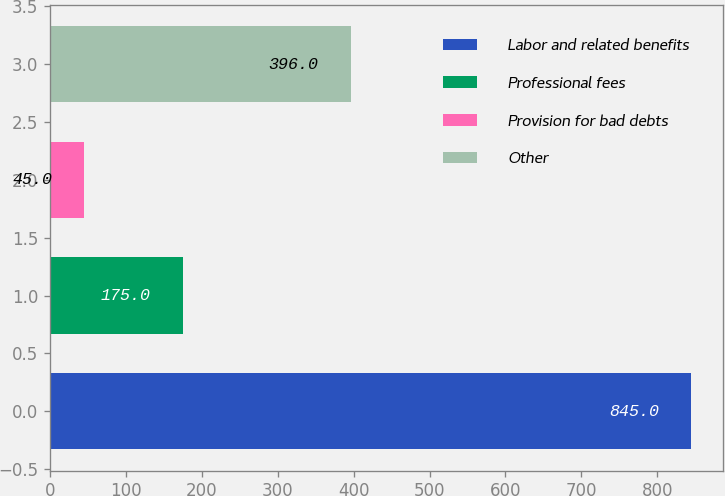Convert chart to OTSL. <chart><loc_0><loc_0><loc_500><loc_500><bar_chart><fcel>Labor and related benefits<fcel>Professional fees<fcel>Provision for bad debts<fcel>Other<nl><fcel>845<fcel>175<fcel>45<fcel>396<nl></chart> 